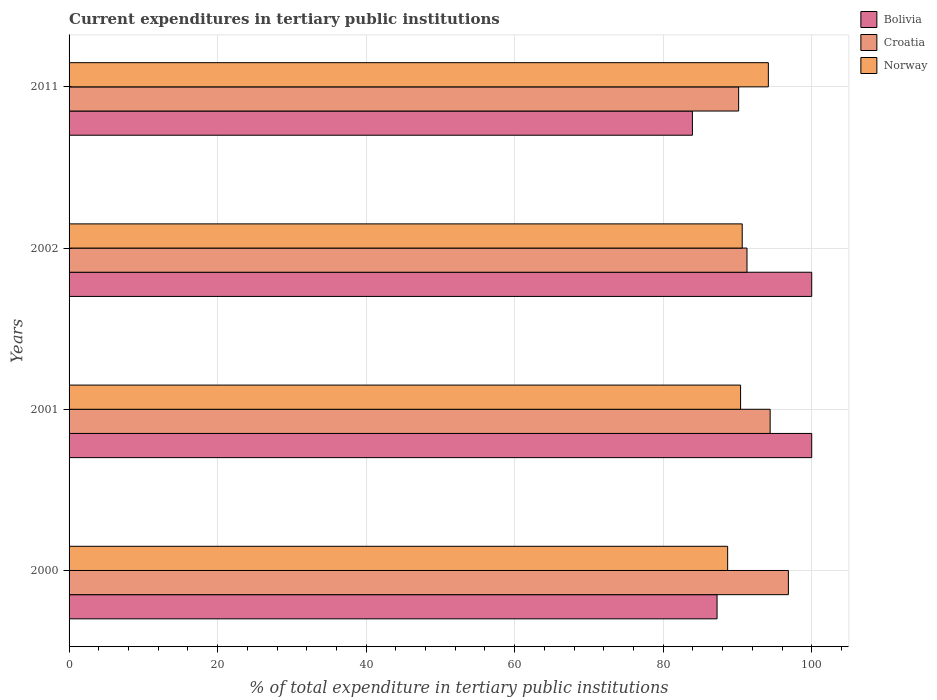How many groups of bars are there?
Keep it short and to the point. 4. Are the number of bars on each tick of the Y-axis equal?
Offer a very short reply. Yes. How many bars are there on the 4th tick from the bottom?
Make the answer very short. 3. What is the label of the 4th group of bars from the top?
Your answer should be very brief. 2000. What is the current expenditures in tertiary public institutions in Bolivia in 2011?
Your answer should be compact. 83.94. Across all years, what is the maximum current expenditures in tertiary public institutions in Croatia?
Make the answer very short. 96.86. Across all years, what is the minimum current expenditures in tertiary public institutions in Norway?
Keep it short and to the point. 88.68. In which year was the current expenditures in tertiary public institutions in Croatia maximum?
Your answer should be compact. 2000. In which year was the current expenditures in tertiary public institutions in Croatia minimum?
Offer a very short reply. 2011. What is the total current expenditures in tertiary public institutions in Norway in the graph?
Make the answer very short. 363.9. What is the difference between the current expenditures in tertiary public institutions in Norway in 2001 and that in 2002?
Your answer should be very brief. -0.22. What is the difference between the current expenditures in tertiary public institutions in Norway in 2000 and the current expenditures in tertiary public institutions in Croatia in 2002?
Give a very brief answer. -2.6. What is the average current expenditures in tertiary public institutions in Croatia per year?
Keep it short and to the point. 93.18. In the year 2002, what is the difference between the current expenditures in tertiary public institutions in Bolivia and current expenditures in tertiary public institutions in Norway?
Your answer should be very brief. 9.36. What is the ratio of the current expenditures in tertiary public institutions in Croatia in 2001 to that in 2011?
Your answer should be very brief. 1.05. Is the difference between the current expenditures in tertiary public institutions in Bolivia in 2000 and 2002 greater than the difference between the current expenditures in tertiary public institutions in Norway in 2000 and 2002?
Provide a short and direct response. No. What is the difference between the highest and the second highest current expenditures in tertiary public institutions in Norway?
Offer a terse response. 3.52. What is the difference between the highest and the lowest current expenditures in tertiary public institutions in Norway?
Provide a succinct answer. 5.48. In how many years, is the current expenditures in tertiary public institutions in Croatia greater than the average current expenditures in tertiary public institutions in Croatia taken over all years?
Your response must be concise. 2. What does the 3rd bar from the top in 2011 represents?
Ensure brevity in your answer.  Bolivia. Is it the case that in every year, the sum of the current expenditures in tertiary public institutions in Bolivia and current expenditures in tertiary public institutions in Norway is greater than the current expenditures in tertiary public institutions in Croatia?
Keep it short and to the point. Yes. Are all the bars in the graph horizontal?
Your response must be concise. Yes. What is the difference between two consecutive major ticks on the X-axis?
Ensure brevity in your answer.  20. Does the graph contain any zero values?
Your answer should be very brief. No. Where does the legend appear in the graph?
Ensure brevity in your answer.  Top right. How are the legend labels stacked?
Your response must be concise. Vertical. What is the title of the graph?
Your answer should be very brief. Current expenditures in tertiary public institutions. Does "Fragile and conflict affected situations" appear as one of the legend labels in the graph?
Make the answer very short. No. What is the label or title of the X-axis?
Keep it short and to the point. % of total expenditure in tertiary public institutions. What is the % of total expenditure in tertiary public institutions in Bolivia in 2000?
Your answer should be compact. 87.25. What is the % of total expenditure in tertiary public institutions in Croatia in 2000?
Your answer should be very brief. 96.86. What is the % of total expenditure in tertiary public institutions in Norway in 2000?
Your answer should be very brief. 88.68. What is the % of total expenditure in tertiary public institutions of Croatia in 2001?
Your response must be concise. 94.4. What is the % of total expenditure in tertiary public institutions of Norway in 2001?
Offer a terse response. 90.42. What is the % of total expenditure in tertiary public institutions in Croatia in 2002?
Offer a terse response. 91.28. What is the % of total expenditure in tertiary public institutions of Norway in 2002?
Ensure brevity in your answer.  90.64. What is the % of total expenditure in tertiary public institutions of Bolivia in 2011?
Keep it short and to the point. 83.94. What is the % of total expenditure in tertiary public institutions of Croatia in 2011?
Ensure brevity in your answer.  90.16. What is the % of total expenditure in tertiary public institutions in Norway in 2011?
Offer a terse response. 94.16. Across all years, what is the maximum % of total expenditure in tertiary public institutions in Bolivia?
Your answer should be compact. 100. Across all years, what is the maximum % of total expenditure in tertiary public institutions in Croatia?
Offer a very short reply. 96.86. Across all years, what is the maximum % of total expenditure in tertiary public institutions of Norway?
Ensure brevity in your answer.  94.16. Across all years, what is the minimum % of total expenditure in tertiary public institutions of Bolivia?
Ensure brevity in your answer.  83.94. Across all years, what is the minimum % of total expenditure in tertiary public institutions in Croatia?
Provide a short and direct response. 90.16. Across all years, what is the minimum % of total expenditure in tertiary public institutions of Norway?
Provide a short and direct response. 88.68. What is the total % of total expenditure in tertiary public institutions in Bolivia in the graph?
Ensure brevity in your answer.  371.19. What is the total % of total expenditure in tertiary public institutions in Croatia in the graph?
Give a very brief answer. 372.71. What is the total % of total expenditure in tertiary public institutions in Norway in the graph?
Your response must be concise. 363.9. What is the difference between the % of total expenditure in tertiary public institutions of Bolivia in 2000 and that in 2001?
Give a very brief answer. -12.75. What is the difference between the % of total expenditure in tertiary public institutions in Croatia in 2000 and that in 2001?
Provide a succinct answer. 2.46. What is the difference between the % of total expenditure in tertiary public institutions of Norway in 2000 and that in 2001?
Ensure brevity in your answer.  -1.74. What is the difference between the % of total expenditure in tertiary public institutions of Bolivia in 2000 and that in 2002?
Give a very brief answer. -12.75. What is the difference between the % of total expenditure in tertiary public institutions of Croatia in 2000 and that in 2002?
Offer a terse response. 5.57. What is the difference between the % of total expenditure in tertiary public institutions of Norway in 2000 and that in 2002?
Your answer should be very brief. -1.96. What is the difference between the % of total expenditure in tertiary public institutions of Bolivia in 2000 and that in 2011?
Make the answer very short. 3.32. What is the difference between the % of total expenditure in tertiary public institutions of Croatia in 2000 and that in 2011?
Provide a short and direct response. 6.7. What is the difference between the % of total expenditure in tertiary public institutions of Norway in 2000 and that in 2011?
Your answer should be very brief. -5.48. What is the difference between the % of total expenditure in tertiary public institutions of Bolivia in 2001 and that in 2002?
Provide a short and direct response. 0. What is the difference between the % of total expenditure in tertiary public institutions of Croatia in 2001 and that in 2002?
Give a very brief answer. 3.12. What is the difference between the % of total expenditure in tertiary public institutions of Norway in 2001 and that in 2002?
Ensure brevity in your answer.  -0.22. What is the difference between the % of total expenditure in tertiary public institutions in Bolivia in 2001 and that in 2011?
Provide a short and direct response. 16.06. What is the difference between the % of total expenditure in tertiary public institutions of Croatia in 2001 and that in 2011?
Keep it short and to the point. 4.24. What is the difference between the % of total expenditure in tertiary public institutions in Norway in 2001 and that in 2011?
Ensure brevity in your answer.  -3.74. What is the difference between the % of total expenditure in tertiary public institutions of Bolivia in 2002 and that in 2011?
Provide a succinct answer. 16.06. What is the difference between the % of total expenditure in tertiary public institutions in Croatia in 2002 and that in 2011?
Your response must be concise. 1.12. What is the difference between the % of total expenditure in tertiary public institutions of Norway in 2002 and that in 2011?
Ensure brevity in your answer.  -3.52. What is the difference between the % of total expenditure in tertiary public institutions in Bolivia in 2000 and the % of total expenditure in tertiary public institutions in Croatia in 2001?
Make the answer very short. -7.15. What is the difference between the % of total expenditure in tertiary public institutions of Bolivia in 2000 and the % of total expenditure in tertiary public institutions of Norway in 2001?
Provide a succinct answer. -3.17. What is the difference between the % of total expenditure in tertiary public institutions of Croatia in 2000 and the % of total expenditure in tertiary public institutions of Norway in 2001?
Your answer should be compact. 6.44. What is the difference between the % of total expenditure in tertiary public institutions of Bolivia in 2000 and the % of total expenditure in tertiary public institutions of Croatia in 2002?
Give a very brief answer. -4.03. What is the difference between the % of total expenditure in tertiary public institutions in Bolivia in 2000 and the % of total expenditure in tertiary public institutions in Norway in 2002?
Make the answer very short. -3.39. What is the difference between the % of total expenditure in tertiary public institutions of Croatia in 2000 and the % of total expenditure in tertiary public institutions of Norway in 2002?
Offer a terse response. 6.22. What is the difference between the % of total expenditure in tertiary public institutions in Bolivia in 2000 and the % of total expenditure in tertiary public institutions in Croatia in 2011?
Provide a short and direct response. -2.91. What is the difference between the % of total expenditure in tertiary public institutions of Bolivia in 2000 and the % of total expenditure in tertiary public institutions of Norway in 2011?
Provide a short and direct response. -6.9. What is the difference between the % of total expenditure in tertiary public institutions of Croatia in 2000 and the % of total expenditure in tertiary public institutions of Norway in 2011?
Your answer should be compact. 2.7. What is the difference between the % of total expenditure in tertiary public institutions in Bolivia in 2001 and the % of total expenditure in tertiary public institutions in Croatia in 2002?
Your answer should be very brief. 8.72. What is the difference between the % of total expenditure in tertiary public institutions of Bolivia in 2001 and the % of total expenditure in tertiary public institutions of Norway in 2002?
Offer a terse response. 9.36. What is the difference between the % of total expenditure in tertiary public institutions of Croatia in 2001 and the % of total expenditure in tertiary public institutions of Norway in 2002?
Ensure brevity in your answer.  3.76. What is the difference between the % of total expenditure in tertiary public institutions in Bolivia in 2001 and the % of total expenditure in tertiary public institutions in Croatia in 2011?
Give a very brief answer. 9.84. What is the difference between the % of total expenditure in tertiary public institutions in Bolivia in 2001 and the % of total expenditure in tertiary public institutions in Norway in 2011?
Offer a terse response. 5.84. What is the difference between the % of total expenditure in tertiary public institutions in Croatia in 2001 and the % of total expenditure in tertiary public institutions in Norway in 2011?
Offer a terse response. 0.24. What is the difference between the % of total expenditure in tertiary public institutions of Bolivia in 2002 and the % of total expenditure in tertiary public institutions of Croatia in 2011?
Make the answer very short. 9.84. What is the difference between the % of total expenditure in tertiary public institutions of Bolivia in 2002 and the % of total expenditure in tertiary public institutions of Norway in 2011?
Ensure brevity in your answer.  5.84. What is the difference between the % of total expenditure in tertiary public institutions of Croatia in 2002 and the % of total expenditure in tertiary public institutions of Norway in 2011?
Make the answer very short. -2.87. What is the average % of total expenditure in tertiary public institutions of Bolivia per year?
Provide a succinct answer. 92.8. What is the average % of total expenditure in tertiary public institutions of Croatia per year?
Keep it short and to the point. 93.18. What is the average % of total expenditure in tertiary public institutions in Norway per year?
Offer a very short reply. 90.98. In the year 2000, what is the difference between the % of total expenditure in tertiary public institutions of Bolivia and % of total expenditure in tertiary public institutions of Croatia?
Provide a succinct answer. -9.6. In the year 2000, what is the difference between the % of total expenditure in tertiary public institutions in Bolivia and % of total expenditure in tertiary public institutions in Norway?
Provide a short and direct response. -1.43. In the year 2000, what is the difference between the % of total expenditure in tertiary public institutions in Croatia and % of total expenditure in tertiary public institutions in Norway?
Your response must be concise. 8.18. In the year 2001, what is the difference between the % of total expenditure in tertiary public institutions of Bolivia and % of total expenditure in tertiary public institutions of Croatia?
Offer a terse response. 5.6. In the year 2001, what is the difference between the % of total expenditure in tertiary public institutions in Bolivia and % of total expenditure in tertiary public institutions in Norway?
Offer a terse response. 9.58. In the year 2001, what is the difference between the % of total expenditure in tertiary public institutions of Croatia and % of total expenditure in tertiary public institutions of Norway?
Give a very brief answer. 3.98. In the year 2002, what is the difference between the % of total expenditure in tertiary public institutions in Bolivia and % of total expenditure in tertiary public institutions in Croatia?
Make the answer very short. 8.72. In the year 2002, what is the difference between the % of total expenditure in tertiary public institutions of Bolivia and % of total expenditure in tertiary public institutions of Norway?
Provide a succinct answer. 9.36. In the year 2002, what is the difference between the % of total expenditure in tertiary public institutions of Croatia and % of total expenditure in tertiary public institutions of Norway?
Give a very brief answer. 0.64. In the year 2011, what is the difference between the % of total expenditure in tertiary public institutions of Bolivia and % of total expenditure in tertiary public institutions of Croatia?
Make the answer very short. -6.23. In the year 2011, what is the difference between the % of total expenditure in tertiary public institutions in Bolivia and % of total expenditure in tertiary public institutions in Norway?
Provide a succinct answer. -10.22. In the year 2011, what is the difference between the % of total expenditure in tertiary public institutions in Croatia and % of total expenditure in tertiary public institutions in Norway?
Your answer should be compact. -4. What is the ratio of the % of total expenditure in tertiary public institutions of Bolivia in 2000 to that in 2001?
Your response must be concise. 0.87. What is the ratio of the % of total expenditure in tertiary public institutions of Croatia in 2000 to that in 2001?
Ensure brevity in your answer.  1.03. What is the ratio of the % of total expenditure in tertiary public institutions of Norway in 2000 to that in 2001?
Ensure brevity in your answer.  0.98. What is the ratio of the % of total expenditure in tertiary public institutions of Bolivia in 2000 to that in 2002?
Give a very brief answer. 0.87. What is the ratio of the % of total expenditure in tertiary public institutions in Croatia in 2000 to that in 2002?
Your answer should be compact. 1.06. What is the ratio of the % of total expenditure in tertiary public institutions of Norway in 2000 to that in 2002?
Make the answer very short. 0.98. What is the ratio of the % of total expenditure in tertiary public institutions in Bolivia in 2000 to that in 2011?
Your answer should be compact. 1.04. What is the ratio of the % of total expenditure in tertiary public institutions of Croatia in 2000 to that in 2011?
Offer a terse response. 1.07. What is the ratio of the % of total expenditure in tertiary public institutions in Norway in 2000 to that in 2011?
Your response must be concise. 0.94. What is the ratio of the % of total expenditure in tertiary public institutions in Croatia in 2001 to that in 2002?
Keep it short and to the point. 1.03. What is the ratio of the % of total expenditure in tertiary public institutions in Bolivia in 2001 to that in 2011?
Your response must be concise. 1.19. What is the ratio of the % of total expenditure in tertiary public institutions in Croatia in 2001 to that in 2011?
Provide a succinct answer. 1.05. What is the ratio of the % of total expenditure in tertiary public institutions in Norway in 2001 to that in 2011?
Ensure brevity in your answer.  0.96. What is the ratio of the % of total expenditure in tertiary public institutions of Bolivia in 2002 to that in 2011?
Provide a succinct answer. 1.19. What is the ratio of the % of total expenditure in tertiary public institutions of Croatia in 2002 to that in 2011?
Provide a short and direct response. 1.01. What is the ratio of the % of total expenditure in tertiary public institutions in Norway in 2002 to that in 2011?
Provide a short and direct response. 0.96. What is the difference between the highest and the second highest % of total expenditure in tertiary public institutions in Bolivia?
Give a very brief answer. 0. What is the difference between the highest and the second highest % of total expenditure in tertiary public institutions in Croatia?
Give a very brief answer. 2.46. What is the difference between the highest and the second highest % of total expenditure in tertiary public institutions of Norway?
Keep it short and to the point. 3.52. What is the difference between the highest and the lowest % of total expenditure in tertiary public institutions of Bolivia?
Keep it short and to the point. 16.06. What is the difference between the highest and the lowest % of total expenditure in tertiary public institutions of Croatia?
Your answer should be very brief. 6.7. What is the difference between the highest and the lowest % of total expenditure in tertiary public institutions of Norway?
Offer a very short reply. 5.48. 